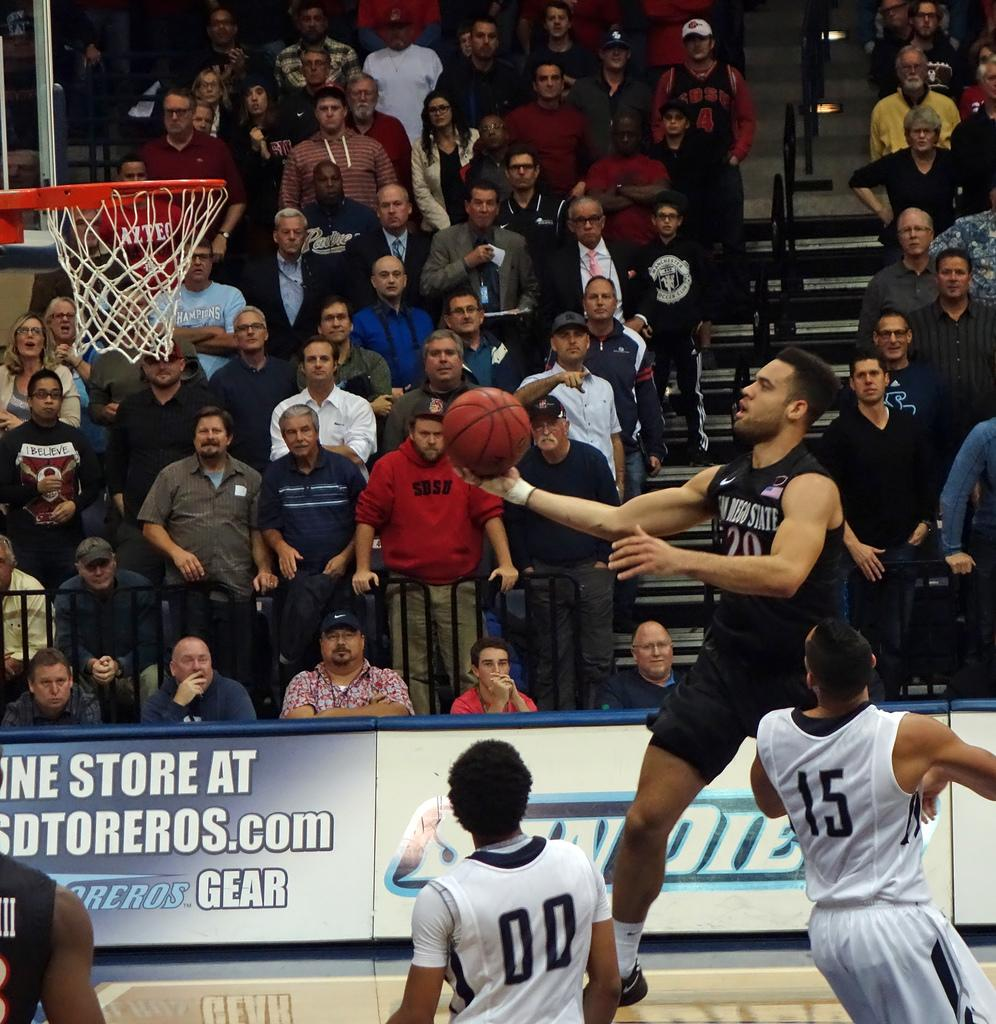Provide a one-sentence caption for the provided image. A hoops player from San Diego State leaps toward the basket, readying for a dunk. 